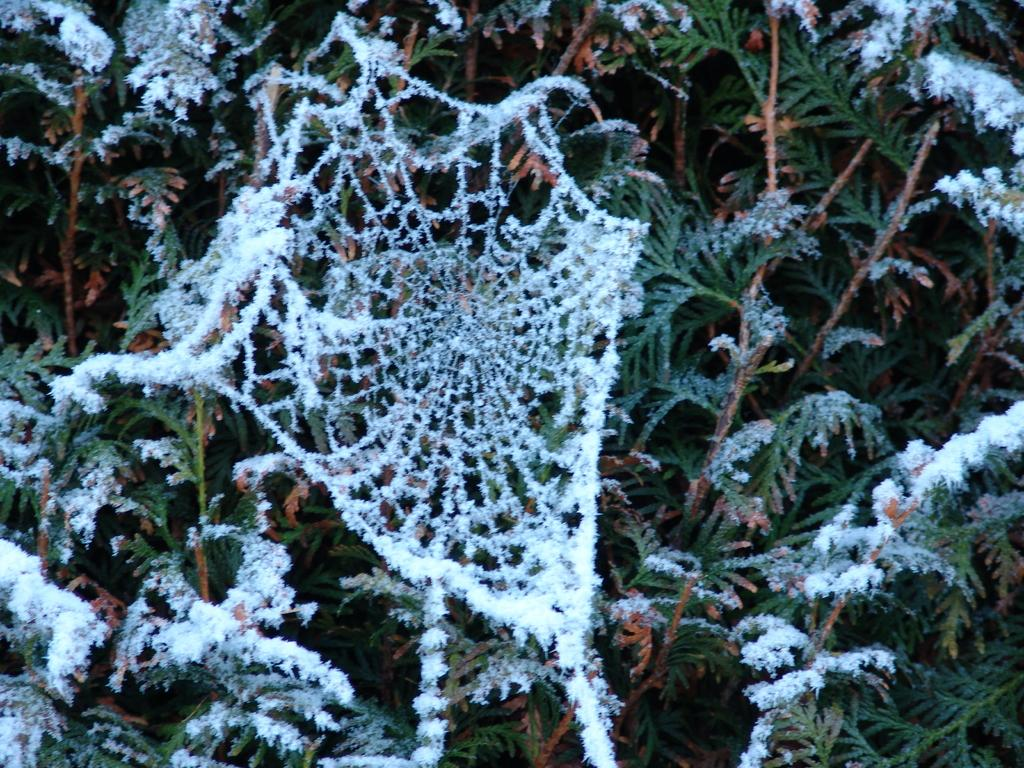Where was the image taken? The image is taken outdoors. What type of plant can be seen in the image? There is a tree with leaves in the image. How is the tree affected by the weather in the image? The tree's stems and branches are covered with snow. What additional detail can be observed in the image? There is a spider web in the image, and it is covered with snow. Reasoning: Let' Let's think step by step in order to produce the conversation. We start by identifying the setting of the image, which is outdoors. Then, we describe the main subject in the image, which is a tree with leaves. Next, we focus on the weather conditions and their impact on the tree, noting that it is covered with snow. Finally, we mention an additional detail in the image, which is the spider web covered with snow. Absurd Question/Answer: What is the tendency of the floor to absorb sound in the image? There is no floor present in the image, as it is taken outdoors. 